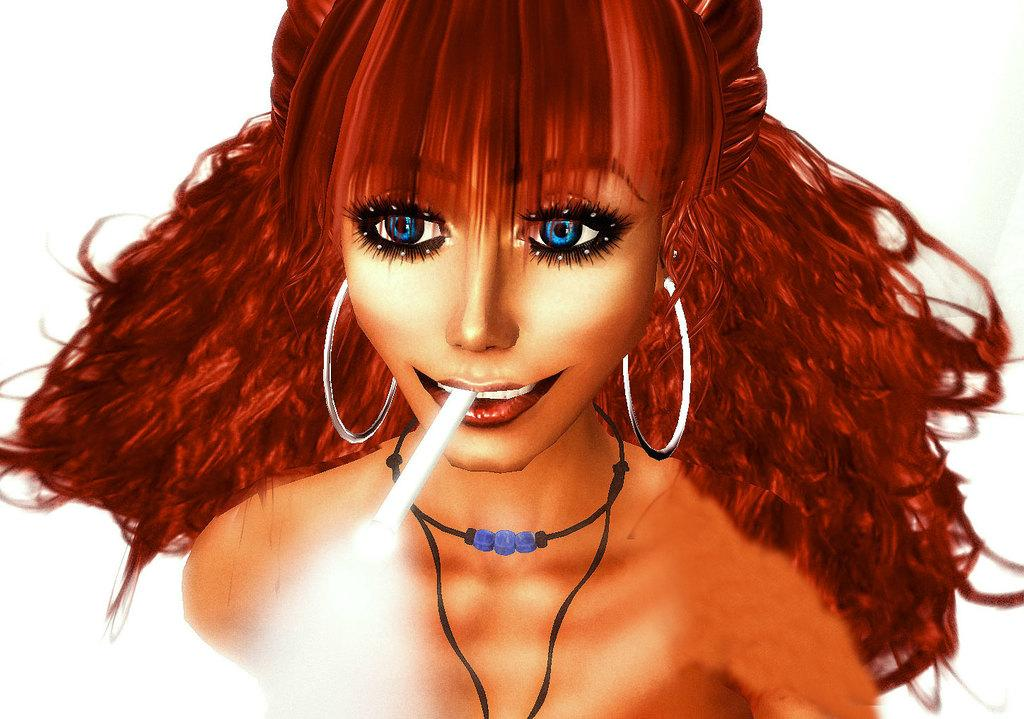What type of image is being described? The image is an animated picture. Can you describe the main subject in the image? There is a lady in the image. What is the lady doing in the image? The lady has a cigarette in her mouth. What type of sofa can be seen in the image? There is no sofa present in the image. 